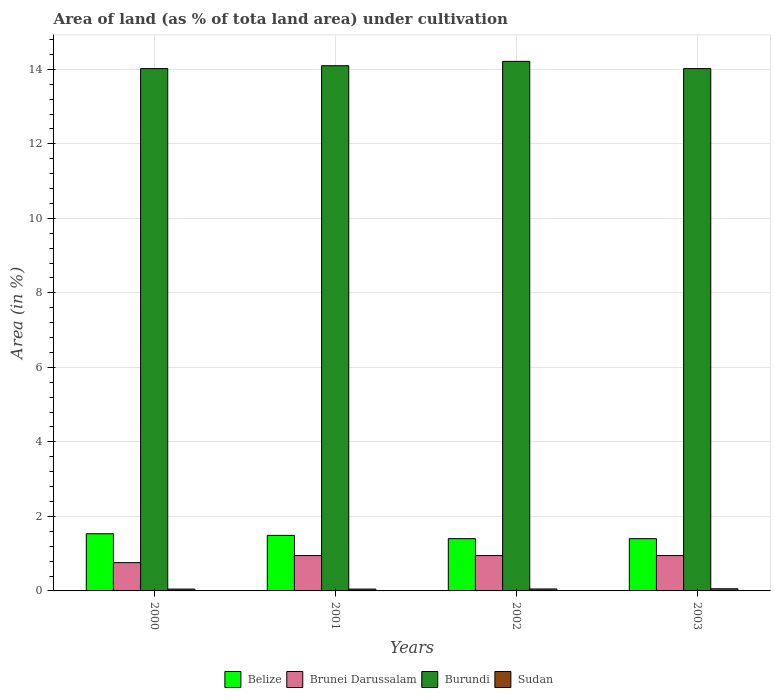How many different coloured bars are there?
Provide a short and direct response. 4. Are the number of bars per tick equal to the number of legend labels?
Offer a very short reply. Yes. Are the number of bars on each tick of the X-axis equal?
Provide a short and direct response. Yes. How many bars are there on the 1st tick from the left?
Your answer should be very brief. 4. How many bars are there on the 1st tick from the right?
Make the answer very short. 4. What is the label of the 2nd group of bars from the left?
Provide a succinct answer. 2001. In how many cases, is the number of bars for a given year not equal to the number of legend labels?
Offer a terse response. 0. What is the percentage of land under cultivation in Burundi in 2000?
Offer a terse response. 14.02. Across all years, what is the maximum percentage of land under cultivation in Sudan?
Offer a terse response. 0.06. Across all years, what is the minimum percentage of land under cultivation in Sudan?
Your response must be concise. 0.05. What is the total percentage of land under cultivation in Sudan in the graph?
Your answer should be very brief. 0.21. What is the difference between the percentage of land under cultivation in Sudan in 2001 and the percentage of land under cultivation in Burundi in 2002?
Your answer should be very brief. -14.16. What is the average percentage of land under cultivation in Burundi per year?
Offer a terse response. 14.09. In the year 2000, what is the difference between the percentage of land under cultivation in Belize and percentage of land under cultivation in Sudan?
Ensure brevity in your answer.  1.49. In how many years, is the percentage of land under cultivation in Brunei Darussalam greater than 3.2 %?
Your answer should be compact. 0. What is the ratio of the percentage of land under cultivation in Sudan in 2001 to that in 2002?
Keep it short and to the point. 0.94. Is the difference between the percentage of land under cultivation in Belize in 2000 and 2003 greater than the difference between the percentage of land under cultivation in Sudan in 2000 and 2003?
Your answer should be very brief. Yes. What is the difference between the highest and the second highest percentage of land under cultivation in Burundi?
Your answer should be compact. 0.12. What is the difference between the highest and the lowest percentage of land under cultivation in Burundi?
Make the answer very short. 0.19. Is the sum of the percentage of land under cultivation in Belize in 2001 and 2003 greater than the maximum percentage of land under cultivation in Brunei Darussalam across all years?
Keep it short and to the point. Yes. Is it the case that in every year, the sum of the percentage of land under cultivation in Brunei Darussalam and percentage of land under cultivation in Belize is greater than the sum of percentage of land under cultivation in Sudan and percentage of land under cultivation in Burundi?
Provide a short and direct response. Yes. What does the 2nd bar from the left in 2003 represents?
Give a very brief answer. Brunei Darussalam. What does the 4th bar from the right in 2003 represents?
Offer a terse response. Belize. Is it the case that in every year, the sum of the percentage of land under cultivation in Belize and percentage of land under cultivation in Burundi is greater than the percentage of land under cultivation in Brunei Darussalam?
Your answer should be compact. Yes. How many bars are there?
Make the answer very short. 16. What is the difference between two consecutive major ticks on the Y-axis?
Your response must be concise. 2. How are the legend labels stacked?
Offer a very short reply. Horizontal. What is the title of the graph?
Ensure brevity in your answer.  Area of land (as % of tota land area) under cultivation. Does "Mauritius" appear as one of the legend labels in the graph?
Your answer should be very brief. No. What is the label or title of the Y-axis?
Provide a short and direct response. Area (in %). What is the Area (in %) in Belize in 2000?
Your response must be concise. 1.53. What is the Area (in %) in Brunei Darussalam in 2000?
Keep it short and to the point. 0.76. What is the Area (in %) in Burundi in 2000?
Your response must be concise. 14.02. What is the Area (in %) in Sudan in 2000?
Give a very brief answer. 0.05. What is the Area (in %) in Belize in 2001?
Provide a succinct answer. 1.49. What is the Area (in %) of Brunei Darussalam in 2001?
Make the answer very short. 0.95. What is the Area (in %) in Burundi in 2001?
Provide a succinct answer. 14.1. What is the Area (in %) in Sudan in 2001?
Keep it short and to the point. 0.05. What is the Area (in %) of Belize in 2002?
Make the answer very short. 1.4. What is the Area (in %) in Brunei Darussalam in 2002?
Offer a very short reply. 0.95. What is the Area (in %) in Burundi in 2002?
Your answer should be compact. 14.21. What is the Area (in %) in Sudan in 2002?
Provide a short and direct response. 0.05. What is the Area (in %) of Belize in 2003?
Make the answer very short. 1.4. What is the Area (in %) in Brunei Darussalam in 2003?
Keep it short and to the point. 0.95. What is the Area (in %) of Burundi in 2003?
Provide a succinct answer. 14.02. What is the Area (in %) of Sudan in 2003?
Make the answer very short. 0.06. Across all years, what is the maximum Area (in %) in Belize?
Keep it short and to the point. 1.53. Across all years, what is the maximum Area (in %) in Brunei Darussalam?
Offer a very short reply. 0.95. Across all years, what is the maximum Area (in %) of Burundi?
Keep it short and to the point. 14.21. Across all years, what is the maximum Area (in %) of Sudan?
Your response must be concise. 0.06. Across all years, what is the minimum Area (in %) in Belize?
Give a very brief answer. 1.4. Across all years, what is the minimum Area (in %) of Brunei Darussalam?
Your answer should be compact. 0.76. Across all years, what is the minimum Area (in %) of Burundi?
Your answer should be very brief. 14.02. Across all years, what is the minimum Area (in %) of Sudan?
Give a very brief answer. 0.05. What is the total Area (in %) in Belize in the graph?
Your answer should be compact. 5.83. What is the total Area (in %) of Brunei Darussalam in the graph?
Provide a succinct answer. 3.61. What is the total Area (in %) of Burundi in the graph?
Provide a short and direct response. 56.35. What is the total Area (in %) of Sudan in the graph?
Offer a very short reply. 0.21. What is the difference between the Area (in %) of Belize in 2000 and that in 2001?
Your response must be concise. 0.04. What is the difference between the Area (in %) of Brunei Darussalam in 2000 and that in 2001?
Offer a terse response. -0.19. What is the difference between the Area (in %) in Burundi in 2000 and that in 2001?
Provide a succinct answer. -0.08. What is the difference between the Area (in %) in Sudan in 2000 and that in 2001?
Provide a short and direct response. 0. What is the difference between the Area (in %) of Belize in 2000 and that in 2002?
Your response must be concise. 0.13. What is the difference between the Area (in %) of Brunei Darussalam in 2000 and that in 2002?
Your answer should be compact. -0.19. What is the difference between the Area (in %) of Burundi in 2000 and that in 2002?
Offer a terse response. -0.19. What is the difference between the Area (in %) in Sudan in 2000 and that in 2002?
Ensure brevity in your answer.  -0. What is the difference between the Area (in %) in Belize in 2000 and that in 2003?
Keep it short and to the point. 0.13. What is the difference between the Area (in %) of Brunei Darussalam in 2000 and that in 2003?
Provide a short and direct response. -0.19. What is the difference between the Area (in %) of Burundi in 2000 and that in 2003?
Provide a short and direct response. 0. What is the difference between the Area (in %) in Sudan in 2000 and that in 2003?
Make the answer very short. -0.01. What is the difference between the Area (in %) in Belize in 2001 and that in 2002?
Your answer should be very brief. 0.09. What is the difference between the Area (in %) of Burundi in 2001 and that in 2002?
Make the answer very short. -0.12. What is the difference between the Area (in %) in Sudan in 2001 and that in 2002?
Ensure brevity in your answer.  -0. What is the difference between the Area (in %) of Belize in 2001 and that in 2003?
Provide a succinct answer. 0.09. What is the difference between the Area (in %) in Burundi in 2001 and that in 2003?
Give a very brief answer. 0.08. What is the difference between the Area (in %) in Sudan in 2001 and that in 2003?
Ensure brevity in your answer.  -0.01. What is the difference between the Area (in %) in Brunei Darussalam in 2002 and that in 2003?
Ensure brevity in your answer.  0. What is the difference between the Area (in %) of Burundi in 2002 and that in 2003?
Ensure brevity in your answer.  0.19. What is the difference between the Area (in %) of Sudan in 2002 and that in 2003?
Your answer should be very brief. -0.01. What is the difference between the Area (in %) of Belize in 2000 and the Area (in %) of Brunei Darussalam in 2001?
Ensure brevity in your answer.  0.59. What is the difference between the Area (in %) in Belize in 2000 and the Area (in %) in Burundi in 2001?
Your answer should be very brief. -12.56. What is the difference between the Area (in %) in Belize in 2000 and the Area (in %) in Sudan in 2001?
Keep it short and to the point. 1.49. What is the difference between the Area (in %) in Brunei Darussalam in 2000 and the Area (in %) in Burundi in 2001?
Offer a terse response. -13.34. What is the difference between the Area (in %) in Brunei Darussalam in 2000 and the Area (in %) in Sudan in 2001?
Provide a succinct answer. 0.71. What is the difference between the Area (in %) of Burundi in 2000 and the Area (in %) of Sudan in 2001?
Provide a short and direct response. 13.97. What is the difference between the Area (in %) in Belize in 2000 and the Area (in %) in Brunei Darussalam in 2002?
Keep it short and to the point. 0.59. What is the difference between the Area (in %) of Belize in 2000 and the Area (in %) of Burundi in 2002?
Your answer should be very brief. -12.68. What is the difference between the Area (in %) in Belize in 2000 and the Area (in %) in Sudan in 2002?
Your response must be concise. 1.48. What is the difference between the Area (in %) in Brunei Darussalam in 2000 and the Area (in %) in Burundi in 2002?
Your response must be concise. -13.45. What is the difference between the Area (in %) in Brunei Darussalam in 2000 and the Area (in %) in Sudan in 2002?
Keep it short and to the point. 0.71. What is the difference between the Area (in %) of Burundi in 2000 and the Area (in %) of Sudan in 2002?
Your response must be concise. 13.97. What is the difference between the Area (in %) in Belize in 2000 and the Area (in %) in Brunei Darussalam in 2003?
Your answer should be very brief. 0.59. What is the difference between the Area (in %) of Belize in 2000 and the Area (in %) of Burundi in 2003?
Offer a very short reply. -12.48. What is the difference between the Area (in %) in Belize in 2000 and the Area (in %) in Sudan in 2003?
Your answer should be compact. 1.48. What is the difference between the Area (in %) of Brunei Darussalam in 2000 and the Area (in %) of Burundi in 2003?
Provide a short and direct response. -13.26. What is the difference between the Area (in %) in Brunei Darussalam in 2000 and the Area (in %) in Sudan in 2003?
Provide a short and direct response. 0.7. What is the difference between the Area (in %) in Burundi in 2000 and the Area (in %) in Sudan in 2003?
Make the answer very short. 13.96. What is the difference between the Area (in %) of Belize in 2001 and the Area (in %) of Brunei Darussalam in 2002?
Ensure brevity in your answer.  0.54. What is the difference between the Area (in %) of Belize in 2001 and the Area (in %) of Burundi in 2002?
Offer a terse response. -12.72. What is the difference between the Area (in %) in Belize in 2001 and the Area (in %) in Sudan in 2002?
Ensure brevity in your answer.  1.44. What is the difference between the Area (in %) in Brunei Darussalam in 2001 and the Area (in %) in Burundi in 2002?
Make the answer very short. -13.26. What is the difference between the Area (in %) in Brunei Darussalam in 2001 and the Area (in %) in Sudan in 2002?
Make the answer very short. 0.9. What is the difference between the Area (in %) in Burundi in 2001 and the Area (in %) in Sudan in 2002?
Your response must be concise. 14.04. What is the difference between the Area (in %) in Belize in 2001 and the Area (in %) in Brunei Darussalam in 2003?
Keep it short and to the point. 0.54. What is the difference between the Area (in %) of Belize in 2001 and the Area (in %) of Burundi in 2003?
Offer a terse response. -12.53. What is the difference between the Area (in %) in Belize in 2001 and the Area (in %) in Sudan in 2003?
Offer a terse response. 1.43. What is the difference between the Area (in %) of Brunei Darussalam in 2001 and the Area (in %) of Burundi in 2003?
Your response must be concise. -13.07. What is the difference between the Area (in %) in Brunei Darussalam in 2001 and the Area (in %) in Sudan in 2003?
Keep it short and to the point. 0.89. What is the difference between the Area (in %) in Burundi in 2001 and the Area (in %) in Sudan in 2003?
Ensure brevity in your answer.  14.04. What is the difference between the Area (in %) of Belize in 2002 and the Area (in %) of Brunei Darussalam in 2003?
Ensure brevity in your answer.  0.45. What is the difference between the Area (in %) in Belize in 2002 and the Area (in %) in Burundi in 2003?
Your answer should be very brief. -12.62. What is the difference between the Area (in %) of Belize in 2002 and the Area (in %) of Sudan in 2003?
Keep it short and to the point. 1.34. What is the difference between the Area (in %) of Brunei Darussalam in 2002 and the Area (in %) of Burundi in 2003?
Provide a short and direct response. -13.07. What is the difference between the Area (in %) of Brunei Darussalam in 2002 and the Area (in %) of Sudan in 2003?
Make the answer very short. 0.89. What is the difference between the Area (in %) of Burundi in 2002 and the Area (in %) of Sudan in 2003?
Your answer should be compact. 14.16. What is the average Area (in %) in Belize per year?
Provide a short and direct response. 1.46. What is the average Area (in %) in Brunei Darussalam per year?
Give a very brief answer. 0.9. What is the average Area (in %) of Burundi per year?
Offer a very short reply. 14.09. What is the average Area (in %) of Sudan per year?
Offer a very short reply. 0.05. In the year 2000, what is the difference between the Area (in %) of Belize and Area (in %) of Brunei Darussalam?
Provide a short and direct response. 0.78. In the year 2000, what is the difference between the Area (in %) in Belize and Area (in %) in Burundi?
Keep it short and to the point. -12.48. In the year 2000, what is the difference between the Area (in %) of Belize and Area (in %) of Sudan?
Provide a succinct answer. 1.49. In the year 2000, what is the difference between the Area (in %) in Brunei Darussalam and Area (in %) in Burundi?
Offer a terse response. -13.26. In the year 2000, what is the difference between the Area (in %) of Brunei Darussalam and Area (in %) of Sudan?
Offer a very short reply. 0.71. In the year 2000, what is the difference between the Area (in %) of Burundi and Area (in %) of Sudan?
Provide a succinct answer. 13.97. In the year 2001, what is the difference between the Area (in %) of Belize and Area (in %) of Brunei Darussalam?
Keep it short and to the point. 0.54. In the year 2001, what is the difference between the Area (in %) of Belize and Area (in %) of Burundi?
Provide a succinct answer. -12.61. In the year 2001, what is the difference between the Area (in %) of Belize and Area (in %) of Sudan?
Provide a succinct answer. 1.44. In the year 2001, what is the difference between the Area (in %) in Brunei Darussalam and Area (in %) in Burundi?
Provide a short and direct response. -13.15. In the year 2001, what is the difference between the Area (in %) in Brunei Darussalam and Area (in %) in Sudan?
Your response must be concise. 0.9. In the year 2001, what is the difference between the Area (in %) in Burundi and Area (in %) in Sudan?
Your response must be concise. 14.05. In the year 2002, what is the difference between the Area (in %) in Belize and Area (in %) in Brunei Darussalam?
Provide a succinct answer. 0.45. In the year 2002, what is the difference between the Area (in %) of Belize and Area (in %) of Burundi?
Your answer should be very brief. -12.81. In the year 2002, what is the difference between the Area (in %) of Belize and Area (in %) of Sudan?
Provide a short and direct response. 1.35. In the year 2002, what is the difference between the Area (in %) of Brunei Darussalam and Area (in %) of Burundi?
Make the answer very short. -13.26. In the year 2002, what is the difference between the Area (in %) in Brunei Darussalam and Area (in %) in Sudan?
Provide a succinct answer. 0.9. In the year 2002, what is the difference between the Area (in %) of Burundi and Area (in %) of Sudan?
Make the answer very short. 14.16. In the year 2003, what is the difference between the Area (in %) in Belize and Area (in %) in Brunei Darussalam?
Make the answer very short. 0.45. In the year 2003, what is the difference between the Area (in %) of Belize and Area (in %) of Burundi?
Make the answer very short. -12.62. In the year 2003, what is the difference between the Area (in %) in Belize and Area (in %) in Sudan?
Offer a terse response. 1.34. In the year 2003, what is the difference between the Area (in %) in Brunei Darussalam and Area (in %) in Burundi?
Provide a short and direct response. -13.07. In the year 2003, what is the difference between the Area (in %) in Brunei Darussalam and Area (in %) in Sudan?
Offer a very short reply. 0.89. In the year 2003, what is the difference between the Area (in %) in Burundi and Area (in %) in Sudan?
Provide a short and direct response. 13.96. What is the ratio of the Area (in %) in Belize in 2000 to that in 2001?
Offer a terse response. 1.03. What is the ratio of the Area (in %) in Burundi in 2000 to that in 2001?
Give a very brief answer. 0.99. What is the ratio of the Area (in %) of Sudan in 2000 to that in 2001?
Keep it short and to the point. 1. What is the ratio of the Area (in %) of Belize in 2000 to that in 2002?
Provide a succinct answer. 1.09. What is the ratio of the Area (in %) in Burundi in 2000 to that in 2002?
Make the answer very short. 0.99. What is the ratio of the Area (in %) of Sudan in 2000 to that in 2002?
Offer a terse response. 0.94. What is the ratio of the Area (in %) in Belize in 2000 to that in 2003?
Give a very brief answer. 1.09. What is the ratio of the Area (in %) in Brunei Darussalam in 2000 to that in 2003?
Provide a short and direct response. 0.8. What is the ratio of the Area (in %) of Sudan in 2000 to that in 2003?
Your answer should be very brief. 0.85. What is the ratio of the Area (in %) in Brunei Darussalam in 2001 to that in 2002?
Offer a terse response. 1. What is the ratio of the Area (in %) in Sudan in 2001 to that in 2002?
Give a very brief answer. 0.94. What is the ratio of the Area (in %) in Belize in 2001 to that in 2003?
Offer a very short reply. 1.06. What is the ratio of the Area (in %) in Burundi in 2001 to that in 2003?
Keep it short and to the point. 1.01. What is the ratio of the Area (in %) of Sudan in 2001 to that in 2003?
Offer a terse response. 0.85. What is the ratio of the Area (in %) of Brunei Darussalam in 2002 to that in 2003?
Your response must be concise. 1. What is the ratio of the Area (in %) in Burundi in 2002 to that in 2003?
Provide a succinct answer. 1.01. What is the ratio of the Area (in %) of Sudan in 2002 to that in 2003?
Offer a terse response. 0.91. What is the difference between the highest and the second highest Area (in %) of Belize?
Provide a short and direct response. 0.04. What is the difference between the highest and the second highest Area (in %) of Burundi?
Give a very brief answer. 0.12. What is the difference between the highest and the second highest Area (in %) in Sudan?
Give a very brief answer. 0.01. What is the difference between the highest and the lowest Area (in %) in Belize?
Your answer should be compact. 0.13. What is the difference between the highest and the lowest Area (in %) in Brunei Darussalam?
Your answer should be compact. 0.19. What is the difference between the highest and the lowest Area (in %) in Burundi?
Your answer should be compact. 0.19. What is the difference between the highest and the lowest Area (in %) in Sudan?
Give a very brief answer. 0.01. 